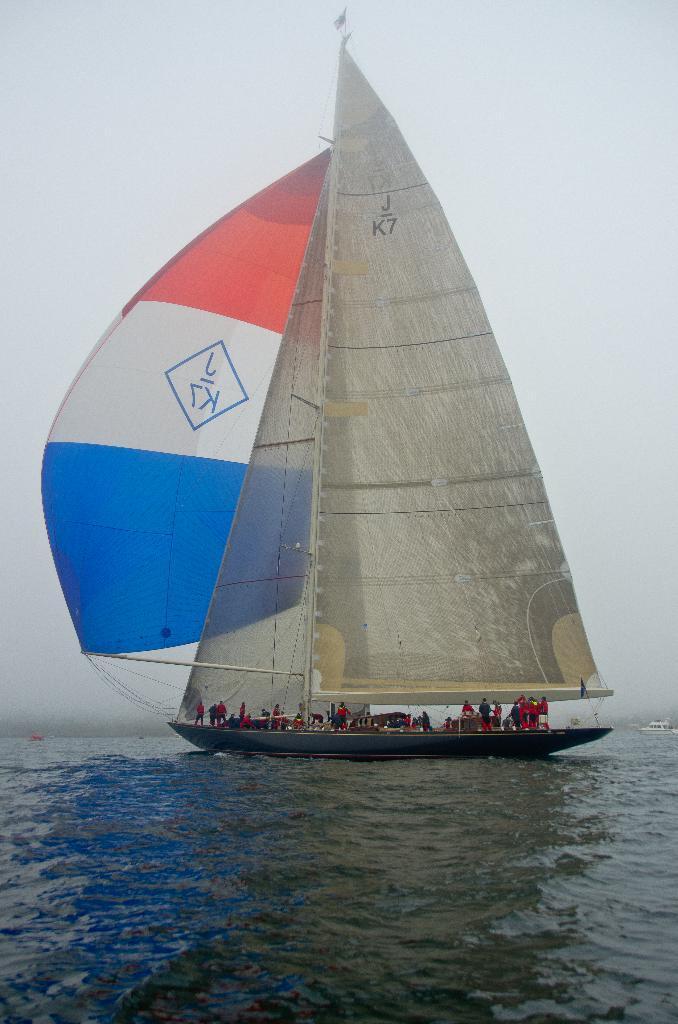Please provide a concise description of this image. In this image, we can see few people are sailing a boat on the water. Here we can see rods and ropes. Background there is a sky. 